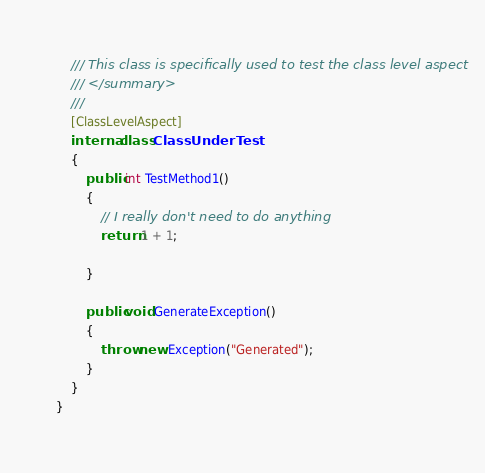<code> <loc_0><loc_0><loc_500><loc_500><_C#_>    /// This class is specifically used to test the class level aspect
    /// </summary>
    ///
    [ClassLevelAspect]
    internal class ClassUnderTest
    {
        public int TestMethod1()
        {
            // I really don't need to do anything
            return 1 + 1;

        }

        public void GenerateException()
        {
            throw new Exception("Generated");
        }
    }
}
</code> 